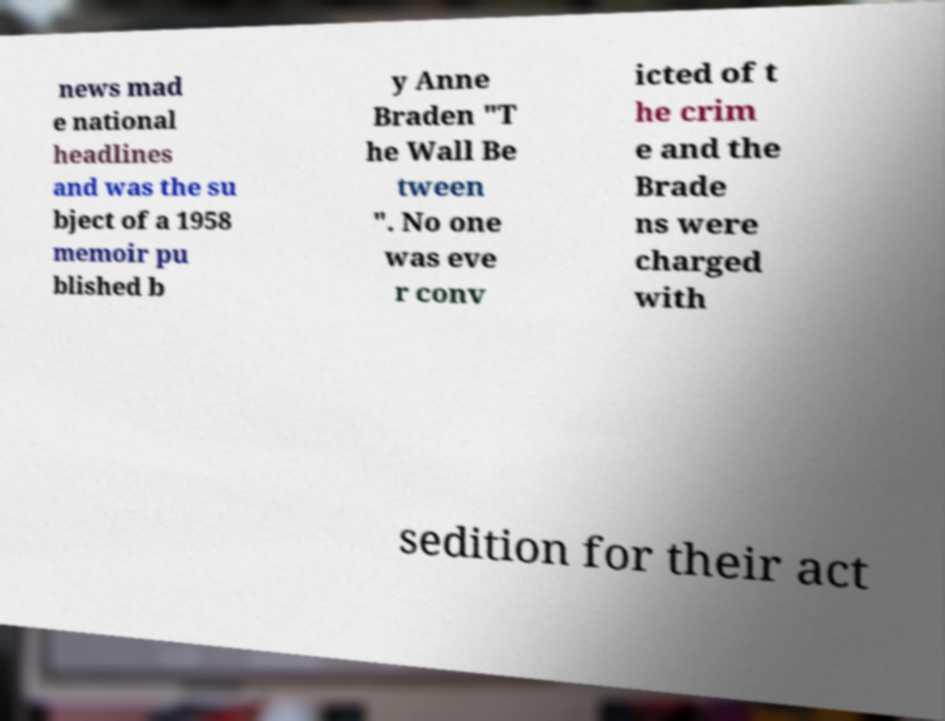For documentation purposes, I need the text within this image transcribed. Could you provide that? news mad e national headlines and was the su bject of a 1958 memoir pu blished b y Anne Braden "T he Wall Be tween ". No one was eve r conv icted of t he crim e and the Brade ns were charged with sedition for their act 